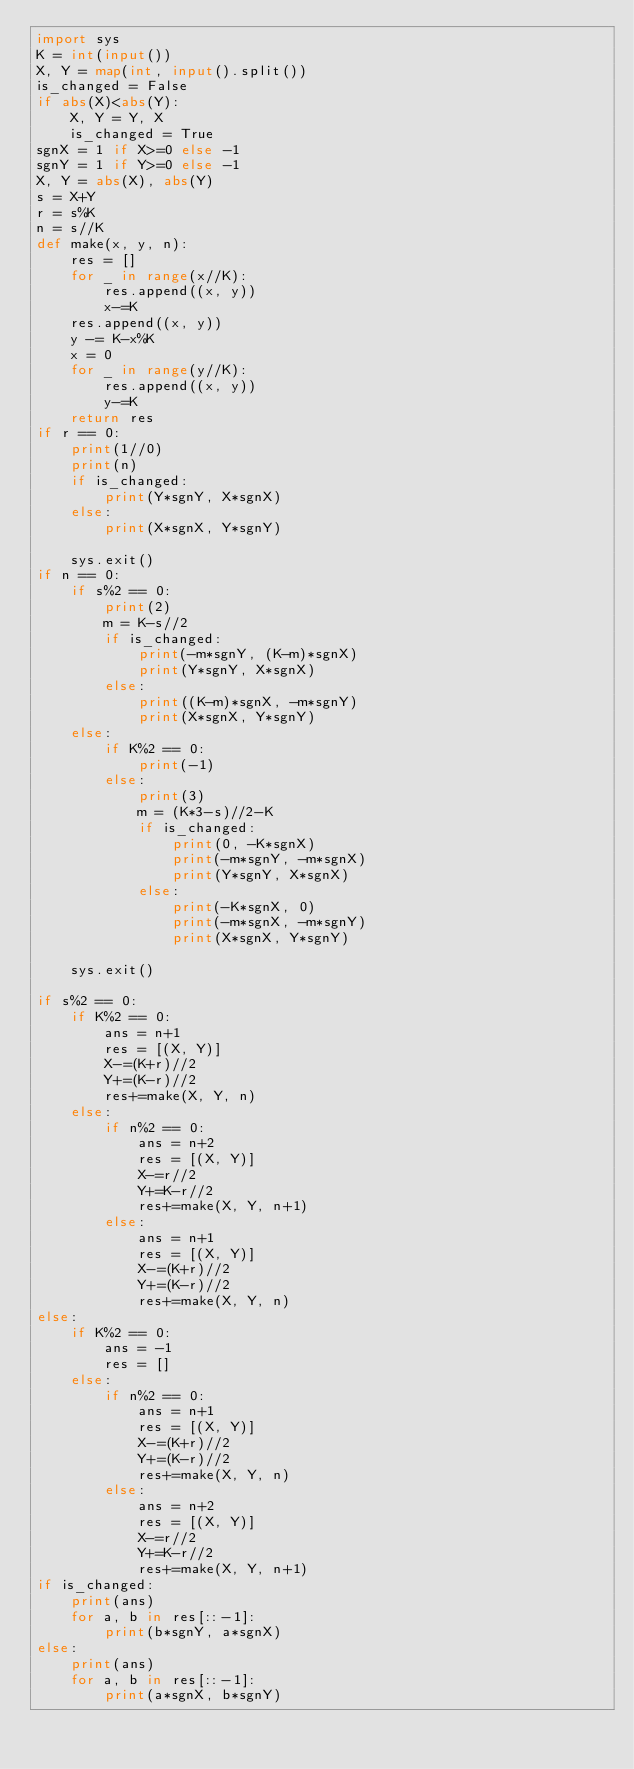Convert code to text. <code><loc_0><loc_0><loc_500><loc_500><_Python_>import sys
K = int(input())
X, Y = map(int, input().split())
is_changed = False
if abs(X)<abs(Y):
    X, Y = Y, X
    is_changed = True
sgnX = 1 if X>=0 else -1
sgnY = 1 if Y>=0 else -1
X, Y = abs(X), abs(Y)
s = X+Y
r = s%K
n = s//K
def make(x, y, n):
    res = []
    for _ in range(x//K):
        res.append((x, y))
        x-=K
    res.append((x, y))
    y -= K-x%K
    x = 0
    for _ in range(y//K):
        res.append((x, y))
        y-=K
    return res
if r == 0:
    print(1//0)
    print(n)
    if is_changed:
        print(Y*sgnY, X*sgnX)
    else:
        print(X*sgnX, Y*sgnY)

    sys.exit()
if n == 0:
    if s%2 == 0:
        print(2)
        m = K-s//2
        if is_changed:
            print(-m*sgnY, (K-m)*sgnX)
            print(Y*sgnY, X*sgnX)
        else:
            print((K-m)*sgnX, -m*sgnY)
            print(X*sgnX, Y*sgnY)
    else:
        if K%2 == 0:
            print(-1)
        else:
            print(3)
            m = (K*3-s)//2-K
            if is_changed:
                print(0, -K*sgnX)
                print(-m*sgnY, -m*sgnX)
                print(Y*sgnY, X*sgnX)
            else:
                print(-K*sgnX, 0)
                print(-m*sgnX, -m*sgnY)
                print(X*sgnX, Y*sgnY)

    sys.exit()

if s%2 == 0:
    if K%2 == 0:
        ans = n+1
        res = [(X, Y)]
        X-=(K+r)//2
        Y+=(K-r)//2
        res+=make(X, Y, n)
    else:
        if n%2 == 0:
            ans = n+2
            res = [(X, Y)]
            X-=r//2
            Y+=K-r//2
            res+=make(X, Y, n+1)
        else:
            ans = n+1
            res = [(X, Y)]
            X-=(K+r)//2
            Y+=(K-r)//2
            res+=make(X, Y, n)
else:
    if K%2 == 0:
        ans = -1
        res = []
    else:
        if n%2 == 0:
            ans = n+1
            res = [(X, Y)]
            X-=(K+r)//2
            Y+=(K-r)//2
            res+=make(X, Y, n)
        else:
            ans = n+2
            res = [(X, Y)]
            X-=r//2
            Y+=K-r//2
            res+=make(X, Y, n+1)
if is_changed:
    print(ans)
    for a, b in res[::-1]:
        print(b*sgnY, a*sgnX)
else:
    print(ans)
    for a, b in res[::-1]:
        print(a*sgnX, b*sgnY)











</code> 